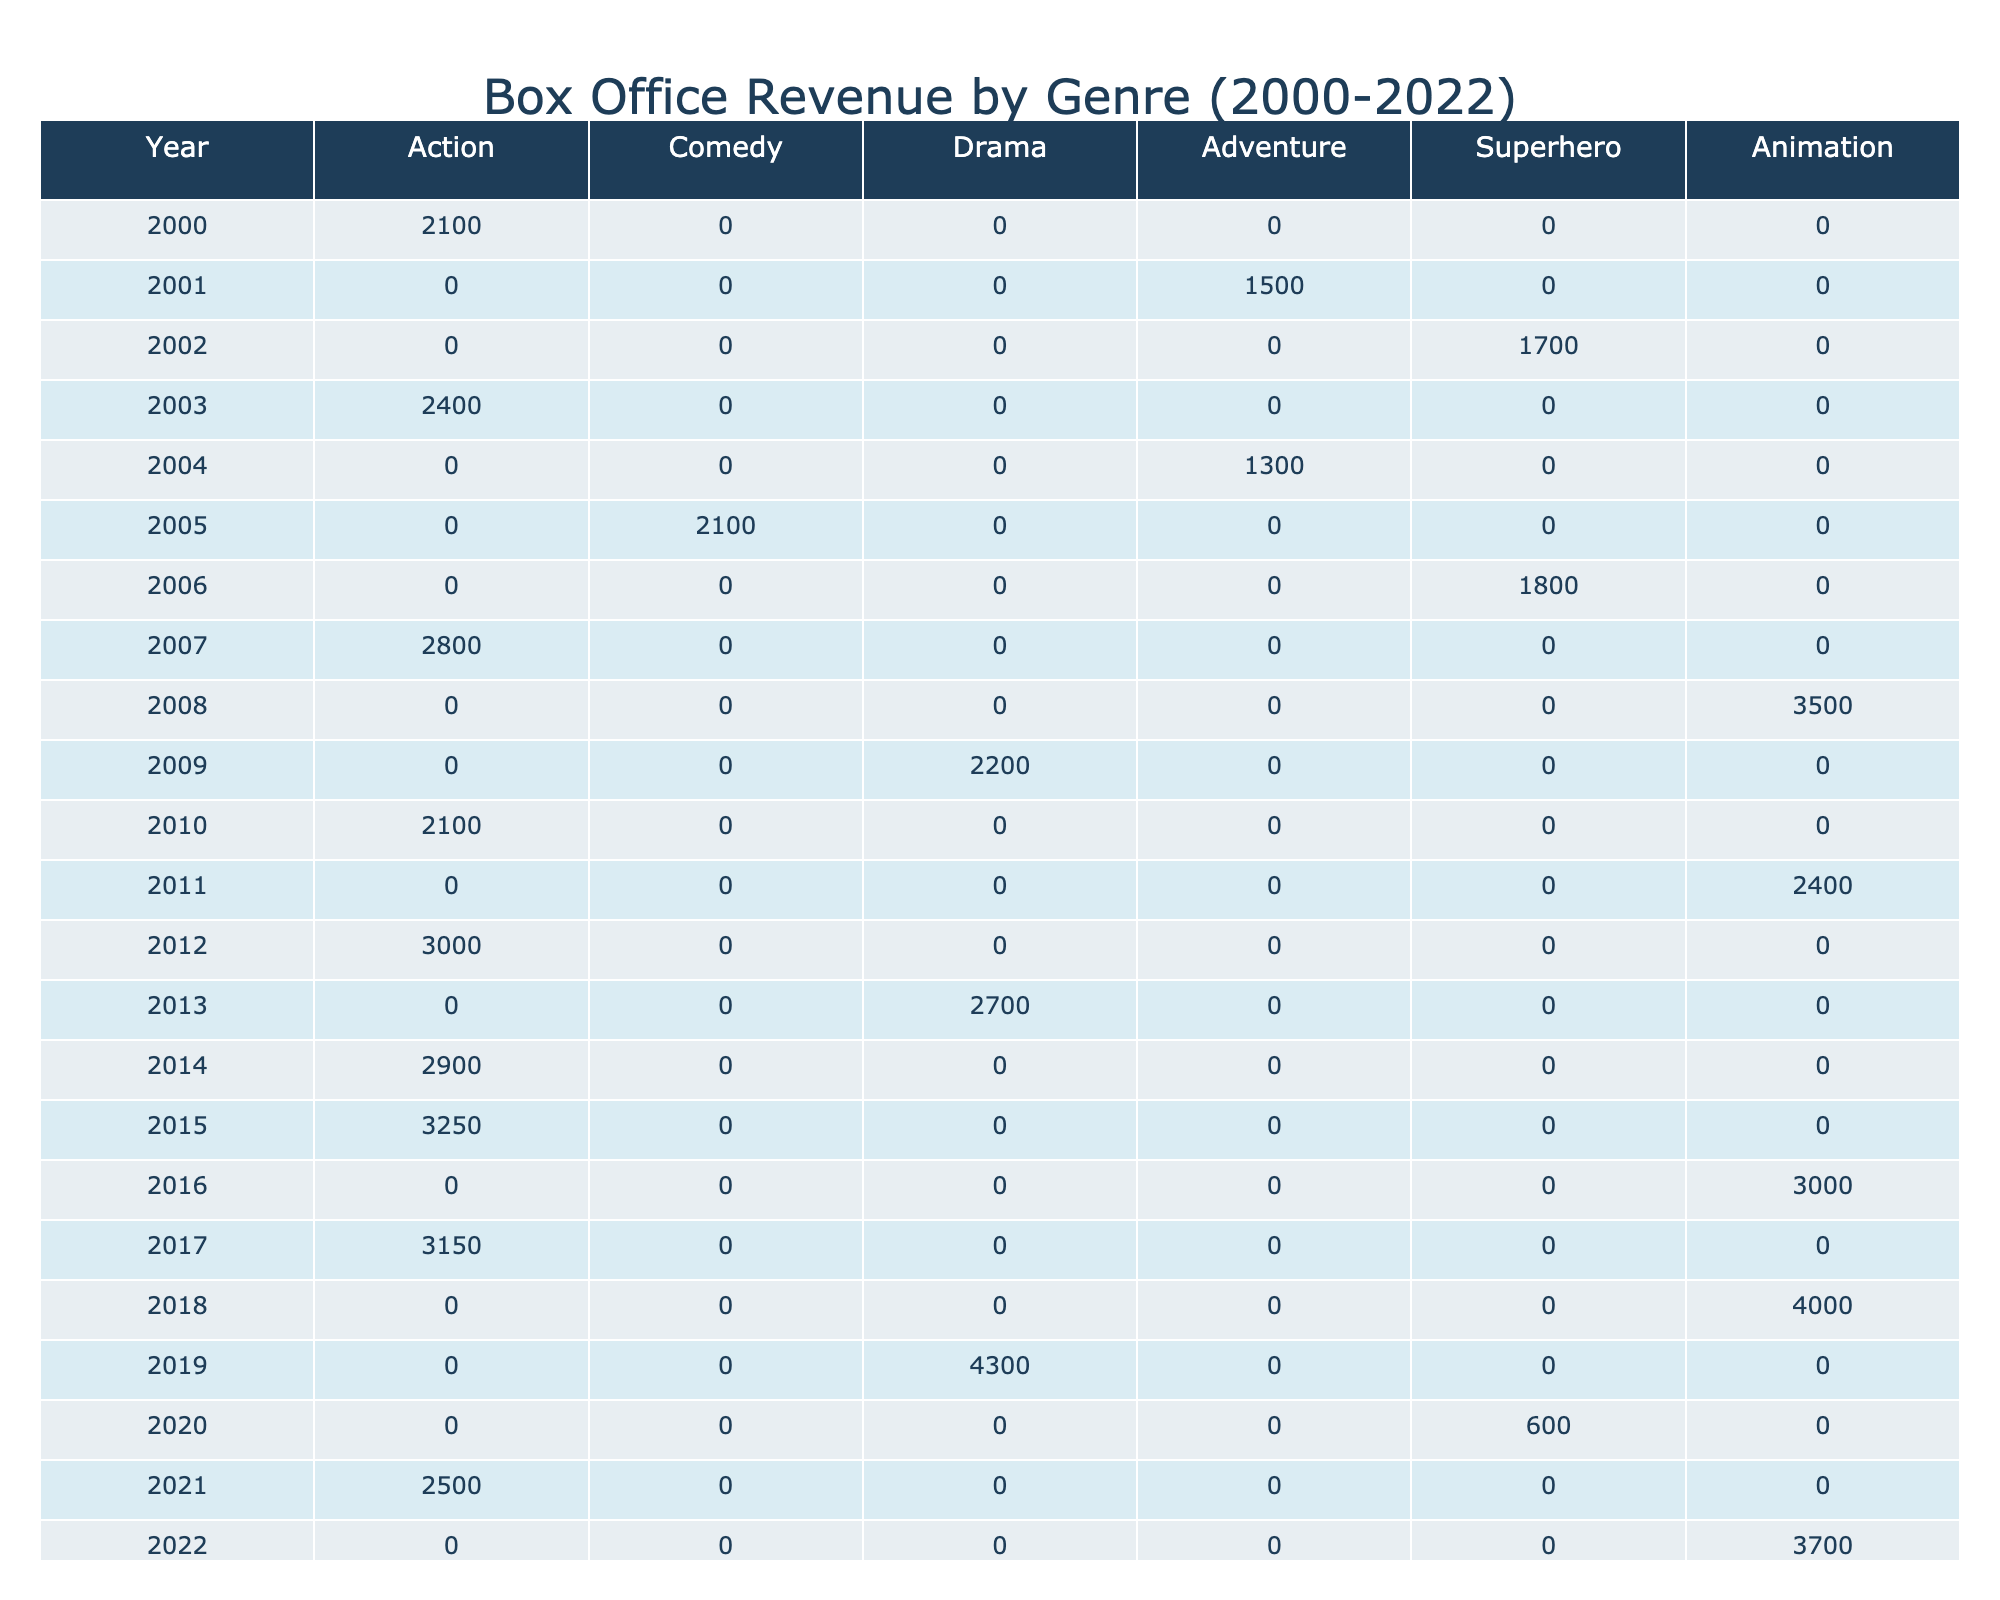What was the highest box office revenue recorded for the Action genre? Looking at the table, the highest box office revenue for the Action genre appears in 2018 with a total of 4000 million.
Answer: 4000 million In which year did the Superhero genre have its lowest box office revenue? The Superhero genre has its lowest box office revenue in 2011, with 2400 million.
Answer: 2400 million What is the average box office revenue for Comedy films over the years? The Comedy genre has recorded revenues of 1500, 1300, and no values for the other years. The average is (1500 + 1300) / 2 = 1400 million.
Answer: 1400 million Did the Adventure genre reach its peak revenue in 2005? Yes, 2005 has the highest recorded revenue for the Adventure genre with 2100 million, and there are no other years listed for this genre.
Answer: Yes Which genre consistently has the highest box office revenues from 2000 to 2022? A review of the table indicates that the Action genre consistently has high revenues, especially in 2018 with 4000 million, surpassing other genres during those years.
Answer: Action In which year did the Animation genre exceed 2000 million box office revenue? The Animation genre exceeded 2000 million in 2009 with 2200 million, in 2013 with 2700 million, and in 2019 with 4300 million.
Answer: Yes How much box office revenue did the Drama genre accumulate in total from 2000 to 2022? For the Drama genre, the values are 1700 (2002), 1800 (2006), and 600 (2020). Summing these gives 1700 + 1800 + 600 = 4100 million.
Answer: 4100 million Which genre had a major revenue drop in 2020? The Drama genre significantly dropped to 600 million in 2020 from a high of 1800 million in 2006.
Answer: Drama What is the difference in box office revenue for Action films between 2012 and 2021? In 2012, the box office revenue for Action was 3000 million, while in 2021 it was 2500 million. The difference is 3000 - 2500 = 500 million.
Answer: 500 million How many times did Animation films surpass 3000 million in box office revenue? The only year Animation surpassed 3000 million was in 2019 with 4300 million; all other years were below this number.
Answer: Once 